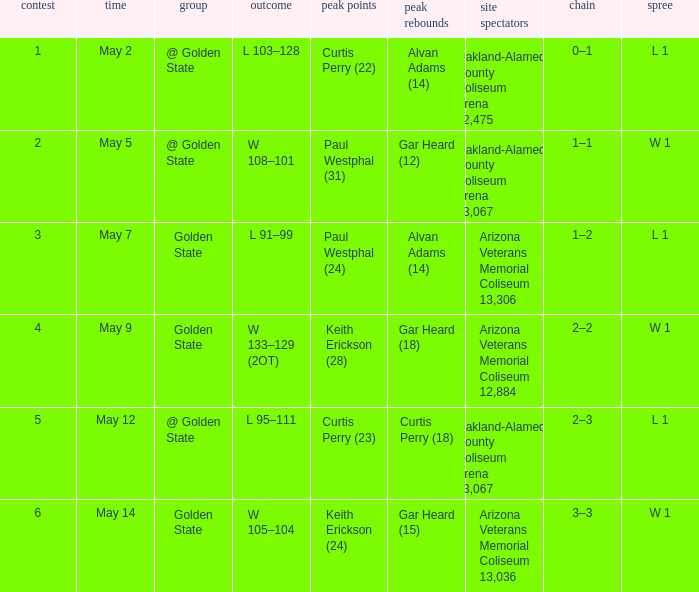How many games had they won or lost in a row on May 9? W 1. 